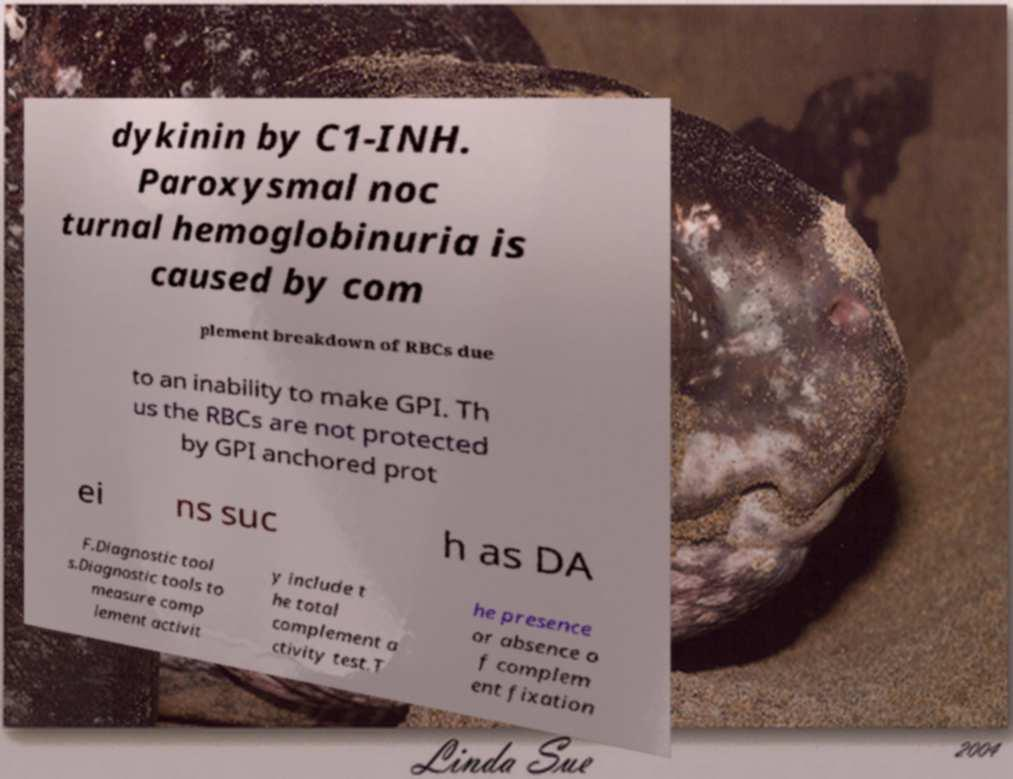For documentation purposes, I need the text within this image transcribed. Could you provide that? dykinin by C1-INH. Paroxysmal noc turnal hemoglobinuria is caused by com plement breakdown of RBCs due to an inability to make GPI. Th us the RBCs are not protected by GPI anchored prot ei ns suc h as DA F.Diagnostic tool s.Diagnostic tools to measure comp lement activit y include t he total complement a ctivity test.T he presence or absence o f complem ent fixation 